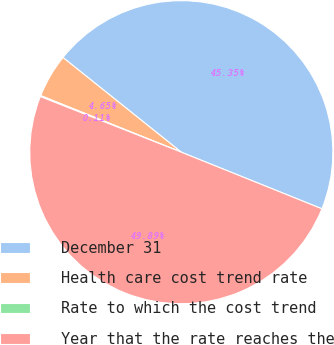Convert chart. <chart><loc_0><loc_0><loc_500><loc_500><pie_chart><fcel>December 31<fcel>Health care cost trend rate<fcel>Rate to which the cost trend<fcel>Year that the rate reaches the<nl><fcel>45.35%<fcel>4.65%<fcel>0.11%<fcel>49.89%<nl></chart> 